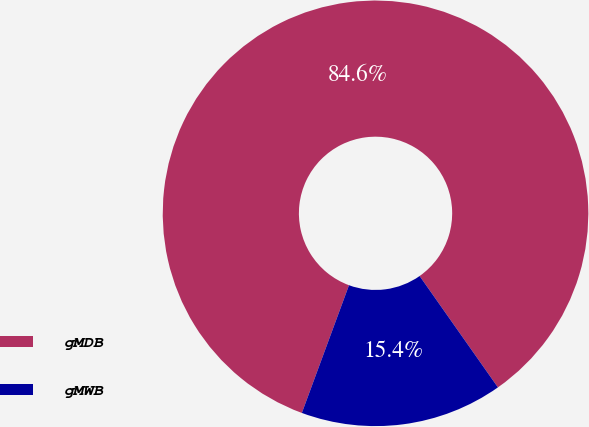Convert chart to OTSL. <chart><loc_0><loc_0><loc_500><loc_500><pie_chart><fcel>gMDB<fcel>gMWB<nl><fcel>84.62%<fcel>15.38%<nl></chart> 